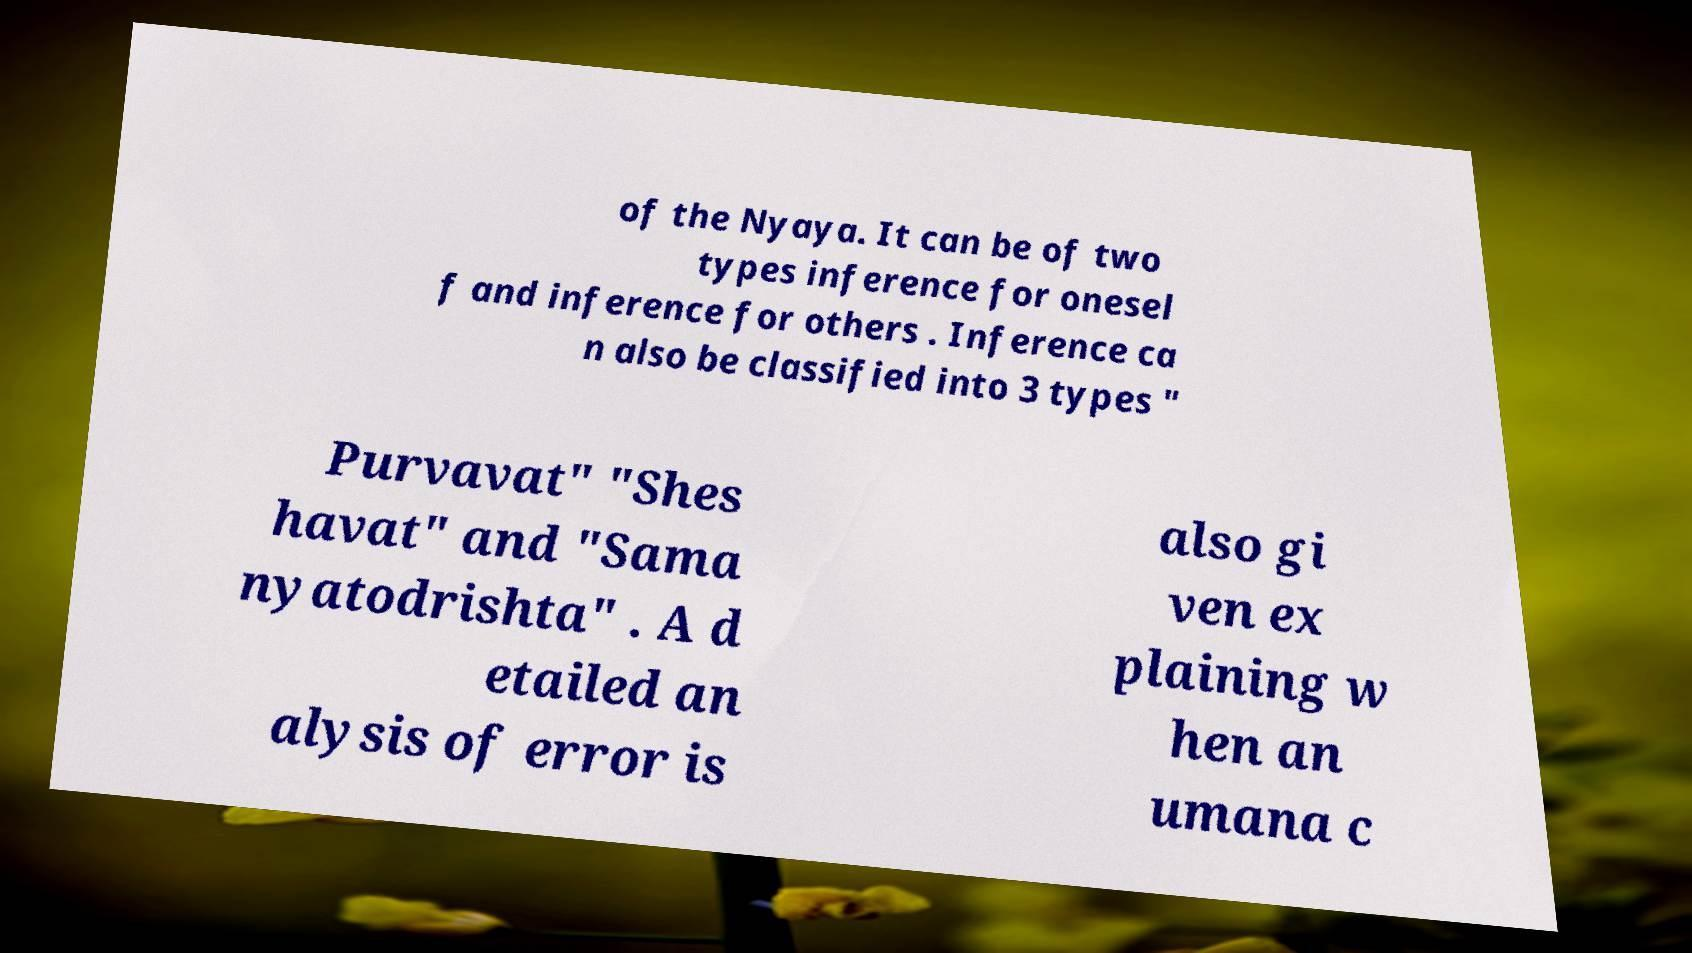I need the written content from this picture converted into text. Can you do that? of the Nyaya. It can be of two types inference for onesel f and inference for others . Inference ca n also be classified into 3 types " Purvavat" "Shes havat" and "Sama nyatodrishta" . A d etailed an alysis of error is also gi ven ex plaining w hen an umana c 